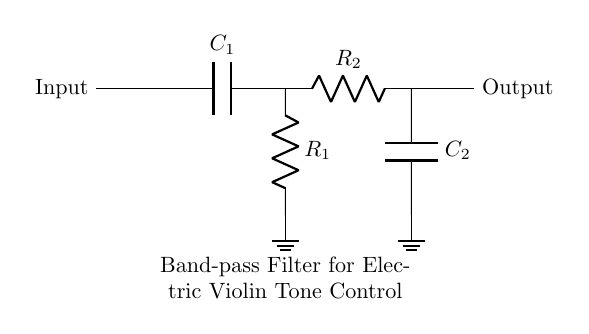What components are used in this circuit? The circuit diagram includes two capacitors (C1, C2) and two resistors (R1, R2). These components are essential for filtering and controlling frequencies.
Answer: Capacitors and resistors What is the function of capacitor C1? Capacitor C1 is part of the high-pass filter section. It allows high frequencies to pass through while blocking low frequencies.
Answer: High-pass filter What is the purpose of the resistor R2? Resistor R2 works in conjunction with capacitor C2 to form a low-pass filter that attenuates frequencies higher than the cutoff frequency while allowing lower frequencies to pass through.
Answer: Low-pass filter What is the intended output of the circuit? The output of the circuit is the isolated specific frequencies that are determined by the values of the capacitors and resistors in the circuit.
Answer: Isolated specific frequencies Which section blocks low frequencies? The high-pass filter section, which consists of capacitor C1 and resistor R1, blocks low frequencies while allowing high frequencies to pass through.
Answer: High-pass filter section How many outputs does the circuit have? The circuit has a single output that represents the filtered signal after passing through the band-pass filter sections.
Answer: One output 